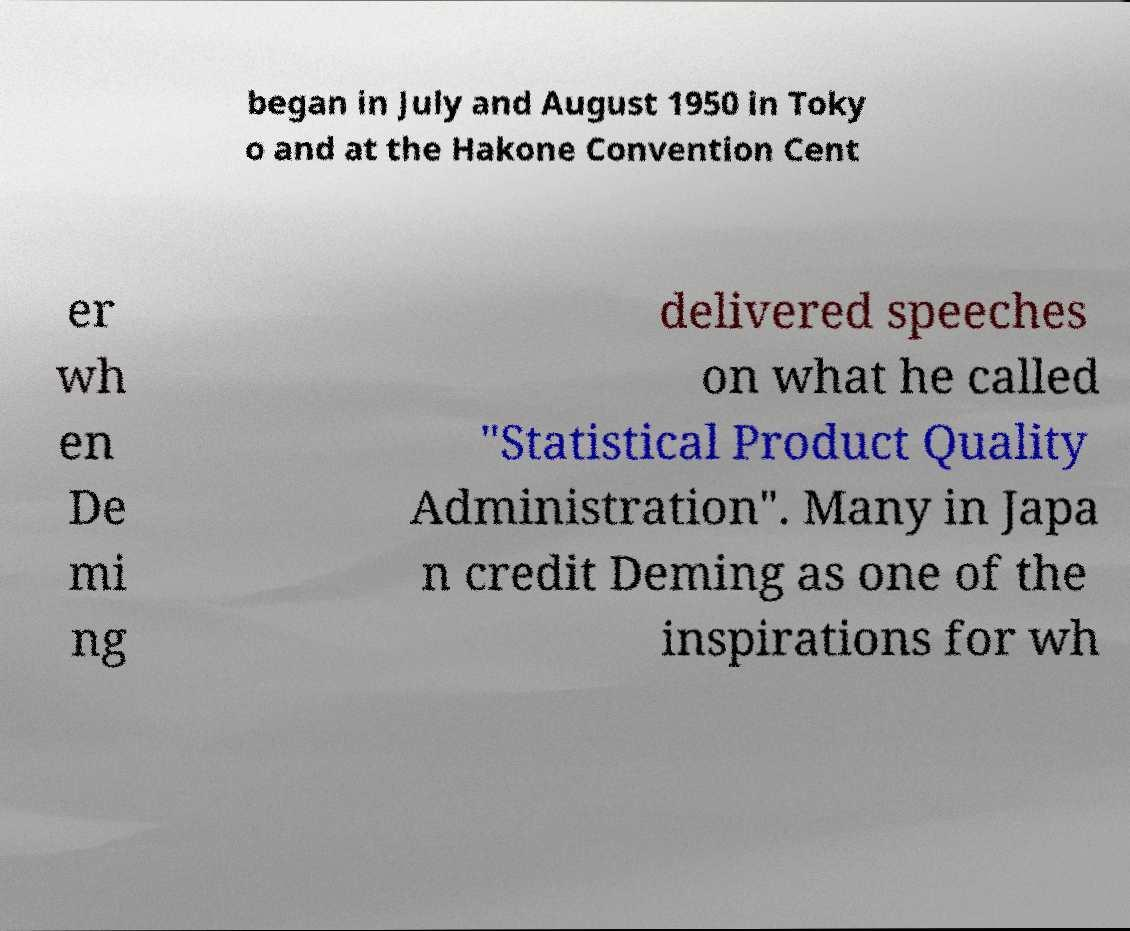For documentation purposes, I need the text within this image transcribed. Could you provide that? began in July and August 1950 in Toky o and at the Hakone Convention Cent er wh en De mi ng delivered speeches on what he called "Statistical Product Quality Administration". Many in Japa n credit Deming as one of the inspirations for wh 